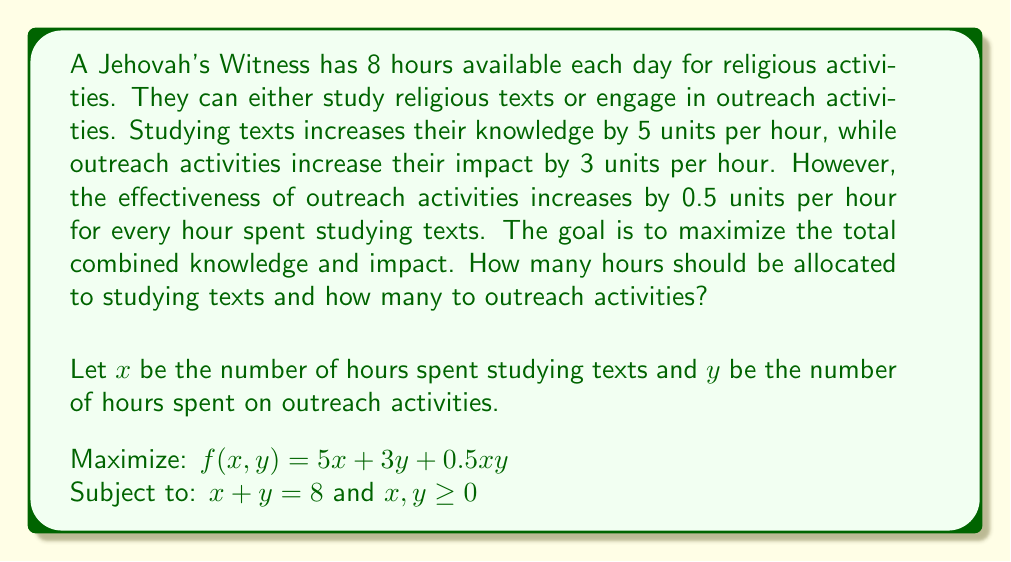Solve this math problem. To solve this optimization problem, we can use the method of substitution:

1) From the constraint $x + y = 8$, we can express $y$ in terms of $x$:
   $y = 8 - x$

2) Substitute this into the objective function:
   $f(x) = 5x + 3(8-x) + 0.5x(8-x)$
   $f(x) = 5x + 24 - 3x + 4x - 0.5x^2$
   $f(x) = -0.5x^2 + 6x + 24$

3) To find the maximum, differentiate $f(x)$ and set it to zero:
   $f'(x) = -x + 6 = 0$
   $x = 6$

4) The second derivative $f''(x) = -1 < 0$, confirming this is a maximum.

5) Calculate $y$:
   $y = 8 - x = 8 - 6 = 2$

6) Verify the solution:
   $x + y = 6 + 2 = 8$ (satisfies the constraint)
   $x, y \geq 0$ (both are non-negative)

7) Calculate the maximum value:
   $f(6,2) = 5(6) + 3(2) + 0.5(6)(2) = 30 + 6 + 6 = 42$
Answer: The optimal allocation is 6 hours for studying texts and 2 hours for outreach activities, resulting in a maximum combined knowledge and impact of 42 units. 